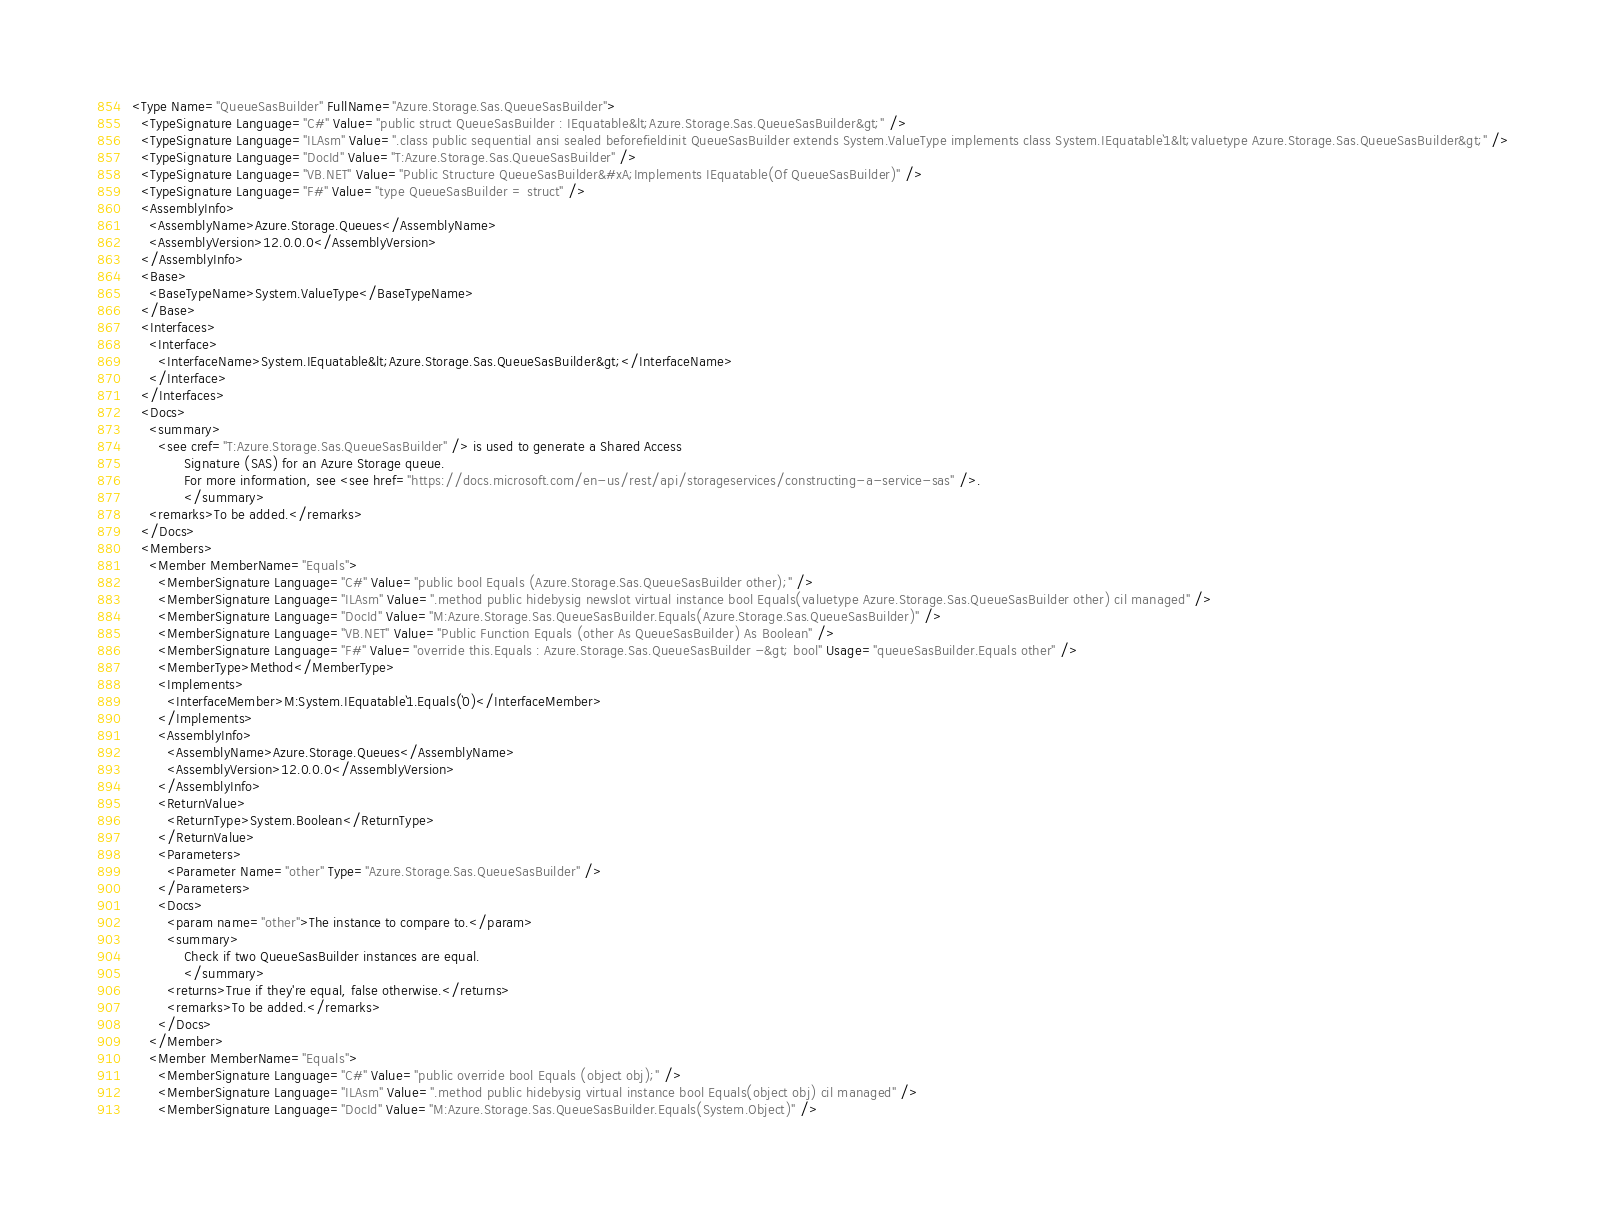<code> <loc_0><loc_0><loc_500><loc_500><_XML_><Type Name="QueueSasBuilder" FullName="Azure.Storage.Sas.QueueSasBuilder">
  <TypeSignature Language="C#" Value="public struct QueueSasBuilder : IEquatable&lt;Azure.Storage.Sas.QueueSasBuilder&gt;" />
  <TypeSignature Language="ILAsm" Value=".class public sequential ansi sealed beforefieldinit QueueSasBuilder extends System.ValueType implements class System.IEquatable`1&lt;valuetype Azure.Storage.Sas.QueueSasBuilder&gt;" />
  <TypeSignature Language="DocId" Value="T:Azure.Storage.Sas.QueueSasBuilder" />
  <TypeSignature Language="VB.NET" Value="Public Structure QueueSasBuilder&#xA;Implements IEquatable(Of QueueSasBuilder)" />
  <TypeSignature Language="F#" Value="type QueueSasBuilder = struct" />
  <AssemblyInfo>
    <AssemblyName>Azure.Storage.Queues</AssemblyName>
    <AssemblyVersion>12.0.0.0</AssemblyVersion>
  </AssemblyInfo>
  <Base>
    <BaseTypeName>System.ValueType</BaseTypeName>
  </Base>
  <Interfaces>
    <Interface>
      <InterfaceName>System.IEquatable&lt;Azure.Storage.Sas.QueueSasBuilder&gt;</InterfaceName>
    </Interface>
  </Interfaces>
  <Docs>
    <summary>
      <see cref="T:Azure.Storage.Sas.QueueSasBuilder" /> is used to generate a Shared Access
            Signature (SAS) for an Azure Storage queue.
            For more information, see <see href="https://docs.microsoft.com/en-us/rest/api/storageservices/constructing-a-service-sas" />.
            </summary>
    <remarks>To be added.</remarks>
  </Docs>
  <Members>
    <Member MemberName="Equals">
      <MemberSignature Language="C#" Value="public bool Equals (Azure.Storage.Sas.QueueSasBuilder other);" />
      <MemberSignature Language="ILAsm" Value=".method public hidebysig newslot virtual instance bool Equals(valuetype Azure.Storage.Sas.QueueSasBuilder other) cil managed" />
      <MemberSignature Language="DocId" Value="M:Azure.Storage.Sas.QueueSasBuilder.Equals(Azure.Storage.Sas.QueueSasBuilder)" />
      <MemberSignature Language="VB.NET" Value="Public Function Equals (other As QueueSasBuilder) As Boolean" />
      <MemberSignature Language="F#" Value="override this.Equals : Azure.Storage.Sas.QueueSasBuilder -&gt; bool" Usage="queueSasBuilder.Equals other" />
      <MemberType>Method</MemberType>
      <Implements>
        <InterfaceMember>M:System.IEquatable`1.Equals(`0)</InterfaceMember>
      </Implements>
      <AssemblyInfo>
        <AssemblyName>Azure.Storage.Queues</AssemblyName>
        <AssemblyVersion>12.0.0.0</AssemblyVersion>
      </AssemblyInfo>
      <ReturnValue>
        <ReturnType>System.Boolean</ReturnType>
      </ReturnValue>
      <Parameters>
        <Parameter Name="other" Type="Azure.Storage.Sas.QueueSasBuilder" />
      </Parameters>
      <Docs>
        <param name="other">The instance to compare to.</param>
        <summary>
            Check if two QueueSasBuilder instances are equal.
            </summary>
        <returns>True if they're equal, false otherwise.</returns>
        <remarks>To be added.</remarks>
      </Docs>
    </Member>
    <Member MemberName="Equals">
      <MemberSignature Language="C#" Value="public override bool Equals (object obj);" />
      <MemberSignature Language="ILAsm" Value=".method public hidebysig virtual instance bool Equals(object obj) cil managed" />
      <MemberSignature Language="DocId" Value="M:Azure.Storage.Sas.QueueSasBuilder.Equals(System.Object)" /></code> 